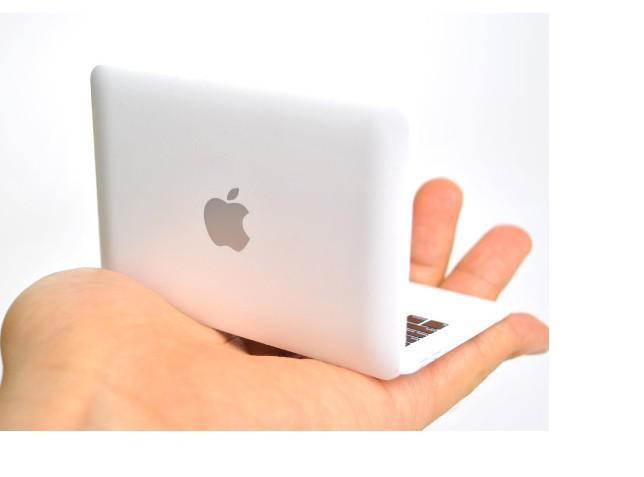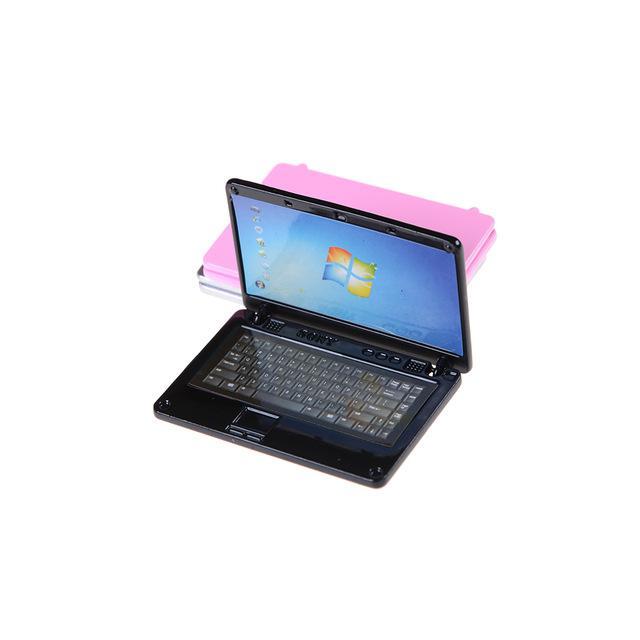The first image is the image on the left, the second image is the image on the right. Assess this claim about the two images: "There are two miniature laptops.". Correct or not? Answer yes or no. Yes. The first image is the image on the left, the second image is the image on the right. For the images displayed, is the sentence "No single image contains more than two devices, and at least one image shows a hand holding a small white open device." factually correct? Answer yes or no. Yes. 